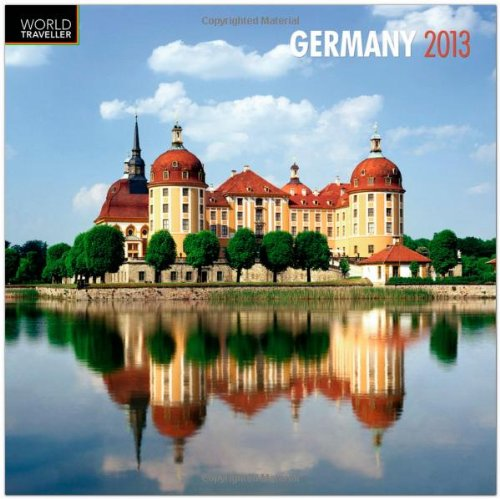Describe the natural setting in the image on this calendar. The calendar image depicts a serene lakeside setting with the edifice mirrored beautifully in the still water, surrounded by lush greenery that creates a calm and picturesque natural environment. 